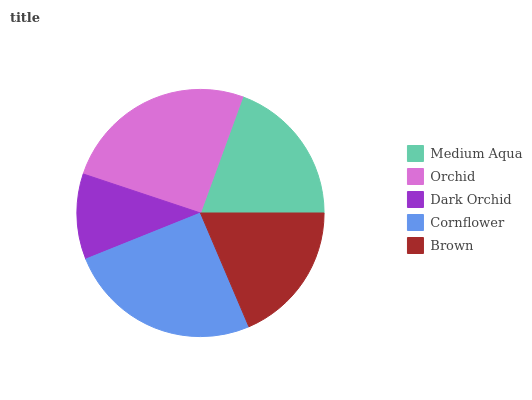Is Dark Orchid the minimum?
Answer yes or no. Yes. Is Orchid the maximum?
Answer yes or no. Yes. Is Orchid the minimum?
Answer yes or no. No. Is Dark Orchid the maximum?
Answer yes or no. No. Is Orchid greater than Dark Orchid?
Answer yes or no. Yes. Is Dark Orchid less than Orchid?
Answer yes or no. Yes. Is Dark Orchid greater than Orchid?
Answer yes or no. No. Is Orchid less than Dark Orchid?
Answer yes or no. No. Is Medium Aqua the high median?
Answer yes or no. Yes. Is Medium Aqua the low median?
Answer yes or no. Yes. Is Brown the high median?
Answer yes or no. No. Is Brown the low median?
Answer yes or no. No. 